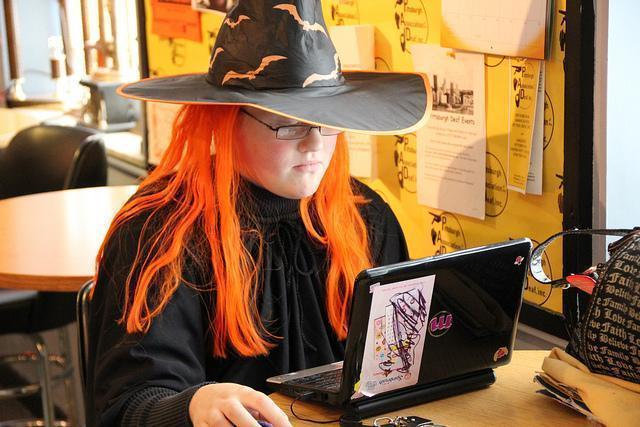What hat does the woman have on?
Choose the right answer from the provided options to respond to the question.
Options: Wool, baseball cap, fedora, witch hat. Witch hat. 